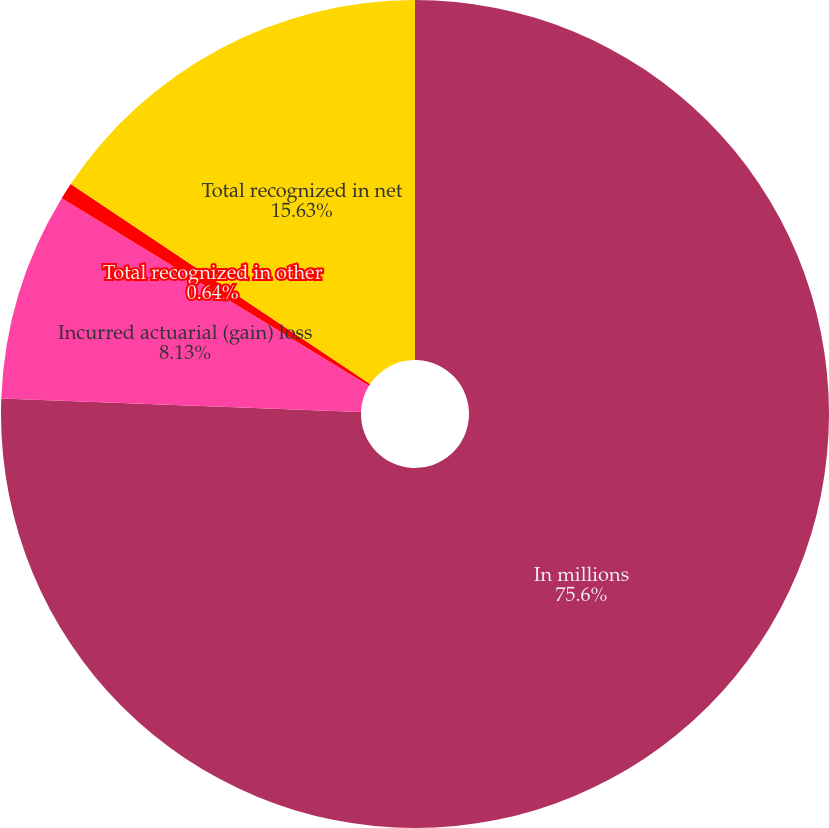Convert chart. <chart><loc_0><loc_0><loc_500><loc_500><pie_chart><fcel>In millions<fcel>Incurred actuarial (gain) loss<fcel>Total recognized in other<fcel>Total recognized in net<nl><fcel>75.6%<fcel>8.13%<fcel>0.64%<fcel>15.63%<nl></chart> 